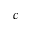<formula> <loc_0><loc_0><loc_500><loc_500>^ { c }</formula> 